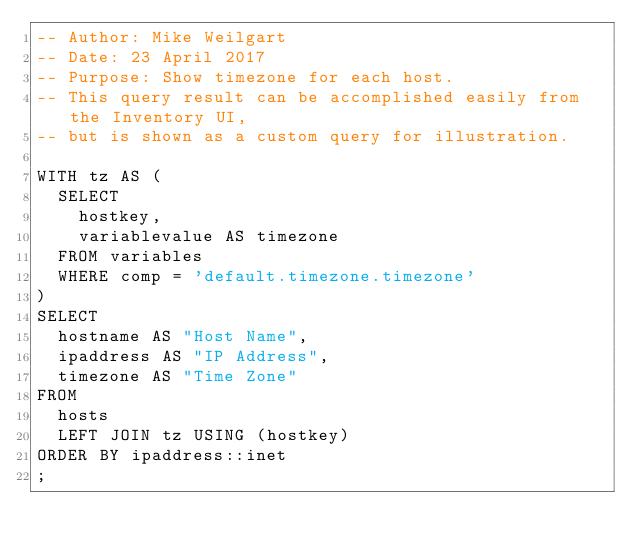Convert code to text. <code><loc_0><loc_0><loc_500><loc_500><_SQL_>-- Author: Mike Weilgart
-- Date: 23 April 2017
-- Purpose: Show timezone for each host.
-- This query result can be accomplished easily from the Inventory UI,
-- but is shown as a custom query for illustration.

WITH tz AS (
  SELECT
    hostkey,
    variablevalue AS timezone
  FROM variables
  WHERE comp = 'default.timezone.timezone'
)
SELECT
  hostname AS "Host Name",
  ipaddress AS "IP Address",
  timezone AS "Time Zone"
FROM
  hosts
  LEFT JOIN tz USING (hostkey)
ORDER BY ipaddress::inet
;
</code> 